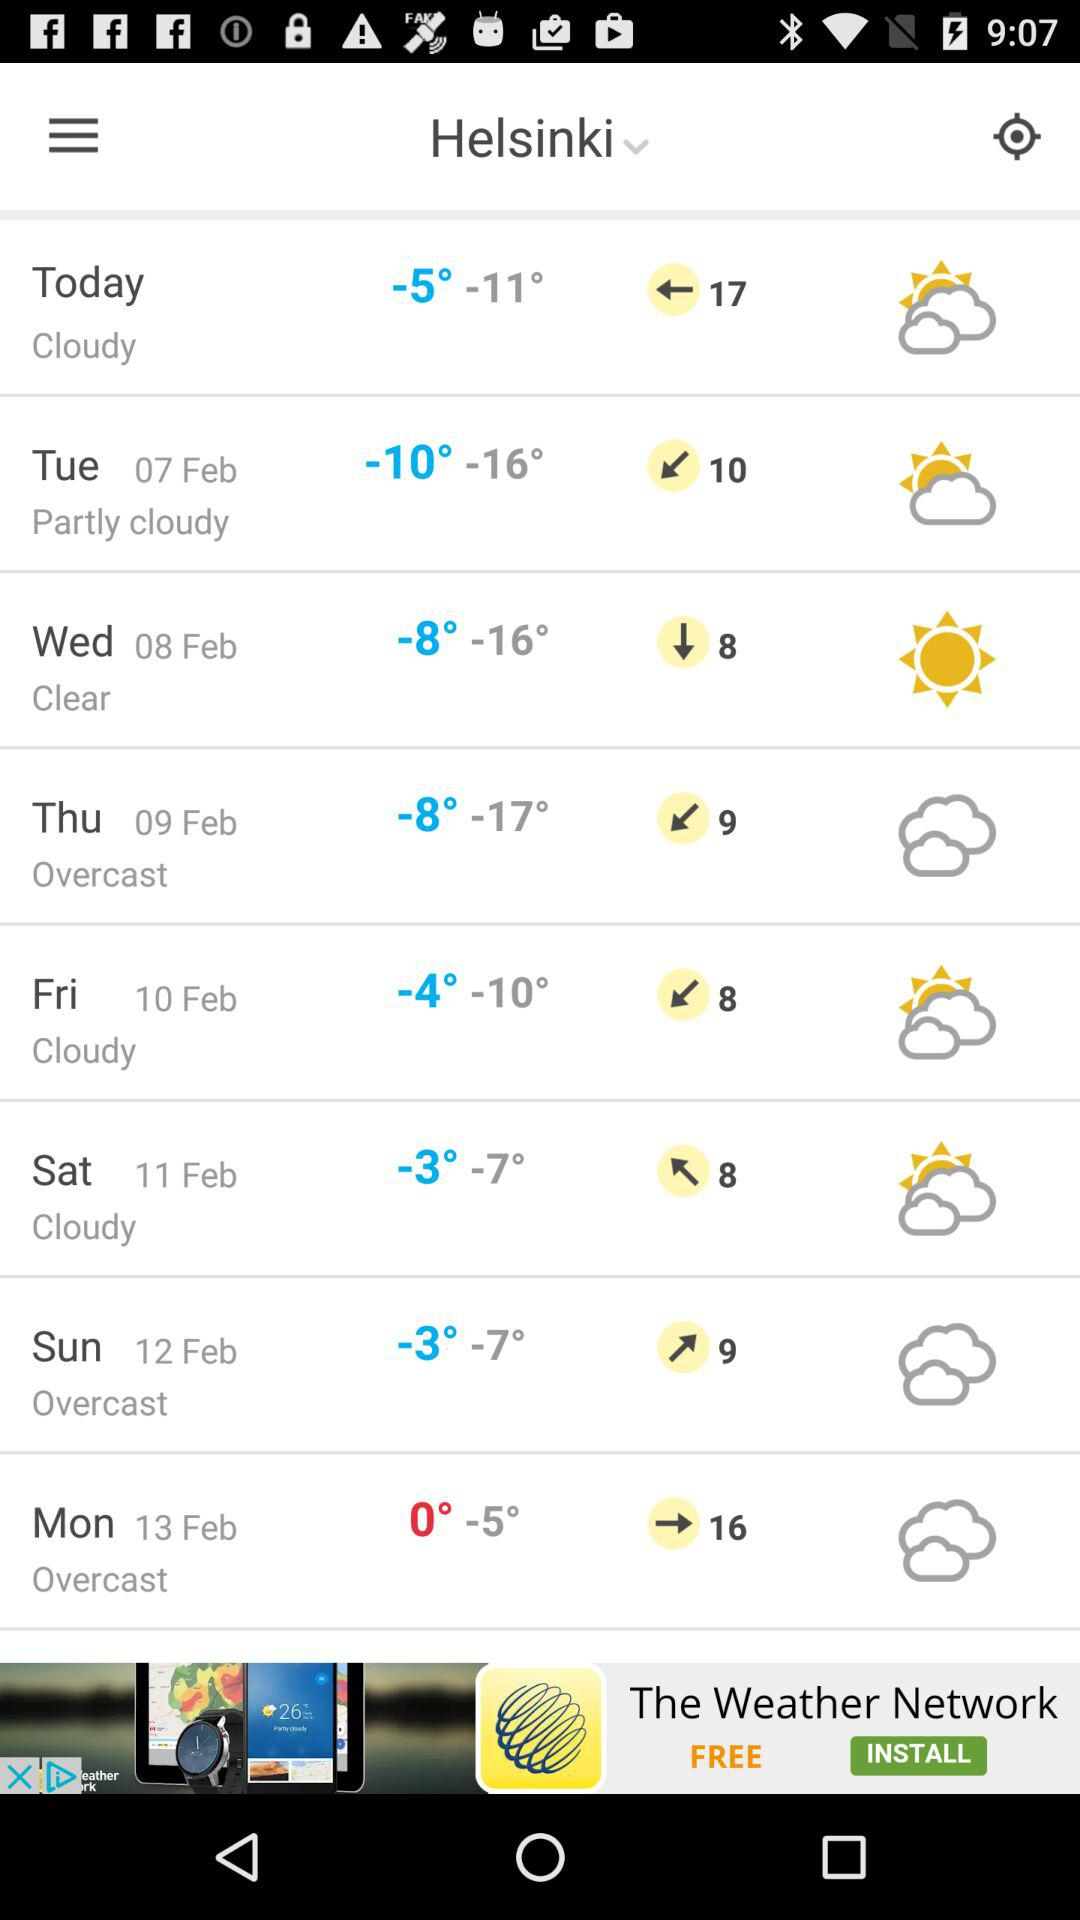How many days are there in the forecast?
Answer the question using a single word or phrase. 8 